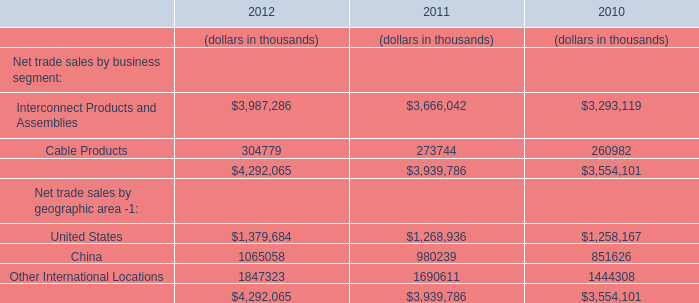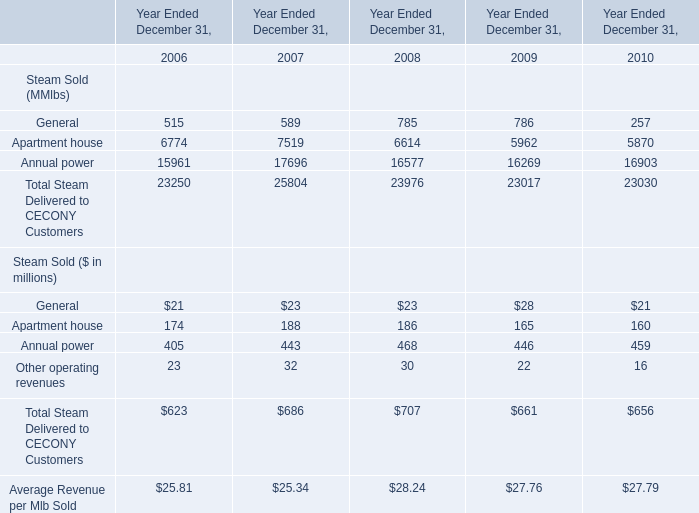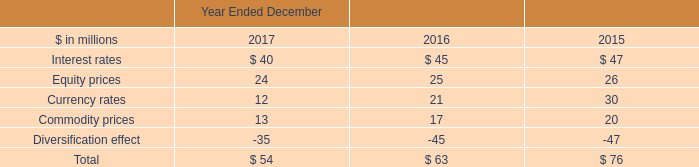In the year with largest amount of General, what's the increasing rate of Apartment house? 
Computations: ((5962 - 6614) / 6614)
Answer: -0.09858. 